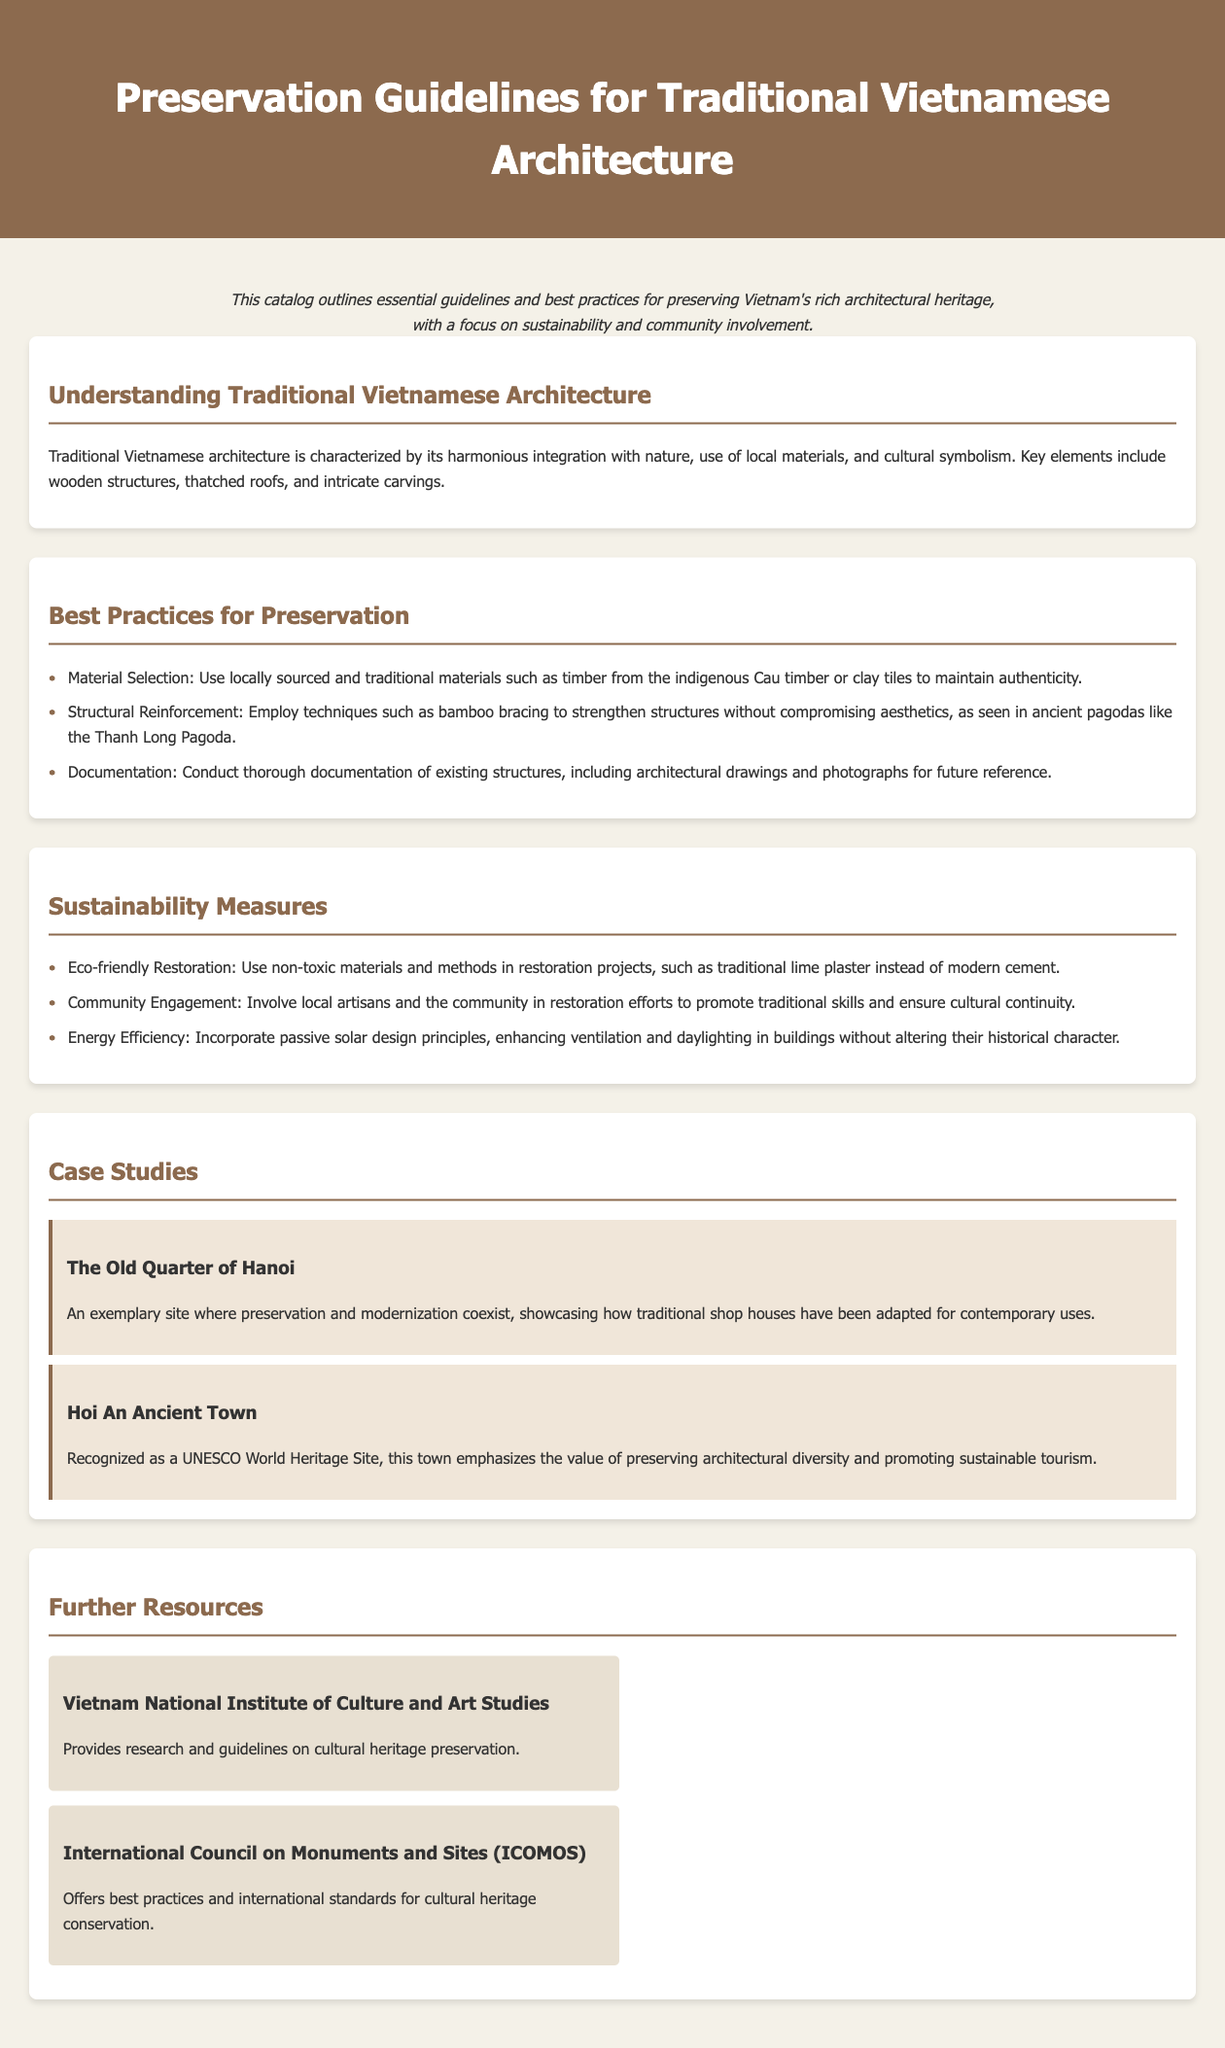What characterizes traditional Vietnamese architecture? Traditional Vietnamese architecture is characterized by its harmonious integration with nature, use of local materials, and cultural symbolism.
Answer: Harmonious integration with nature, local materials, cultural symbolism What eco-friendly method is suggested for restoration projects? The document mentions that eco-friendly restoration should use non-toxic materials and methods, such as traditional lime plaster instead of modern cement.
Answer: Traditional lime plaster What does the case study of Hoi An Ancient Town emphasize? The case study highlights the importance of preserving architectural diversity and promoting sustainable tourism in Hoi An Ancient Town.
Answer: Architectural diversity and sustainable tourism Which material is recommended for structural reinforcement? The document suggests employing bamboo bracing techniques for structural reinforcement in traditional architecture.
Answer: Bamboo bracing What organization's guidelines are provided for cultural heritage preservation? The catalog references the Vietnam National Institute of Culture and Art Studies as a resource for research and guidelines on cultural heritage preservation.
Answer: Vietnam National Institute of Culture and Art Studies How many case studies are presented in the document? The document includes two case studies: The Old Quarter of Hanoi and Hoi An Ancient Town.
Answer: Two What is a key aspect of community engagement in preservation measures? The document states that community engagement involves involving local artisans and the community in restoration efforts to promote traditional skills.
Answer: Involve local artisans and community What is highlighted as a best practice for material selection? Using locally sourced and traditional materials, such as timber from the indigenous Cau timber, is highlighted as a best practice for material selection.
Answer: Timber from the indigenous Cau timber What architectural feature is a characteristic of traditional Vietnamese houses? The characteristic feature mentioned in traditional Vietnamese houses is the thatched roofs.
Answer: Thatched roofs 